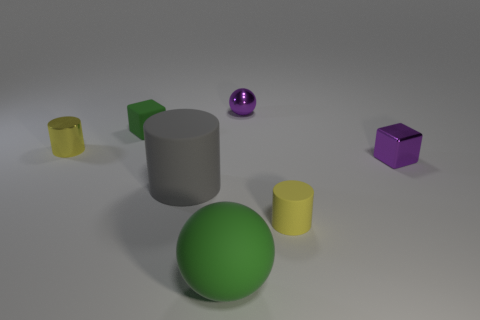There is another yellow thing that is the same shape as the small yellow matte object; what is it made of?
Keep it short and to the point. Metal. Is the small ball the same color as the metal cube?
Offer a terse response. Yes. There is a sphere that is behind the tiny cylinder that is behind the yellow matte object; what is it made of?
Provide a succinct answer. Metal. What is the shape of the object that is the same color as the rubber sphere?
Keep it short and to the point. Cube. Are there any large gray cylinders made of the same material as the big green sphere?
Keep it short and to the point. Yes. Is the material of the tiny green thing the same as the small yellow object that is behind the gray rubber cylinder?
Provide a succinct answer. No. What is the color of the rubber cube that is the same size as the purple shiny block?
Your answer should be very brief. Green. How big is the purple object behind the green object behind the tiny metal cylinder?
Give a very brief answer. Small. Does the tiny rubber cylinder have the same color as the small shiny object on the left side of the large green rubber thing?
Your answer should be very brief. Yes. Are there fewer large green rubber spheres to the right of the yellow matte thing than green cubes?
Give a very brief answer. Yes. 